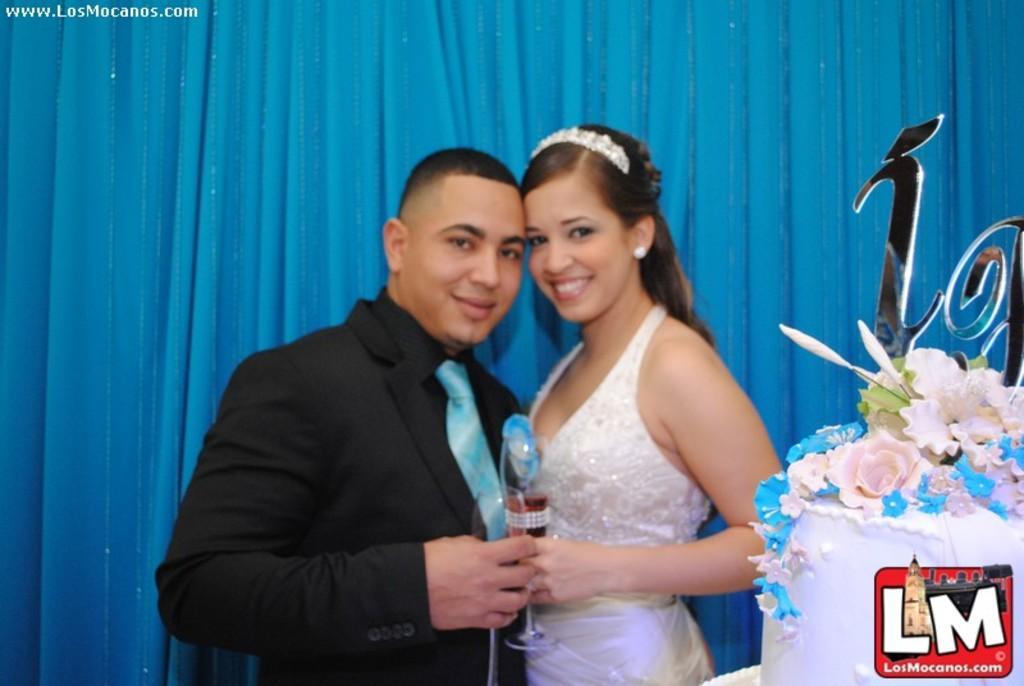How would you summarize this image in a sentence or two? In this Image I can see two people standing and holding something. In front I can see a blue,white and pink color cake. I can see a blue curtain. He is wearing black dress and woman is wearing white dress. 